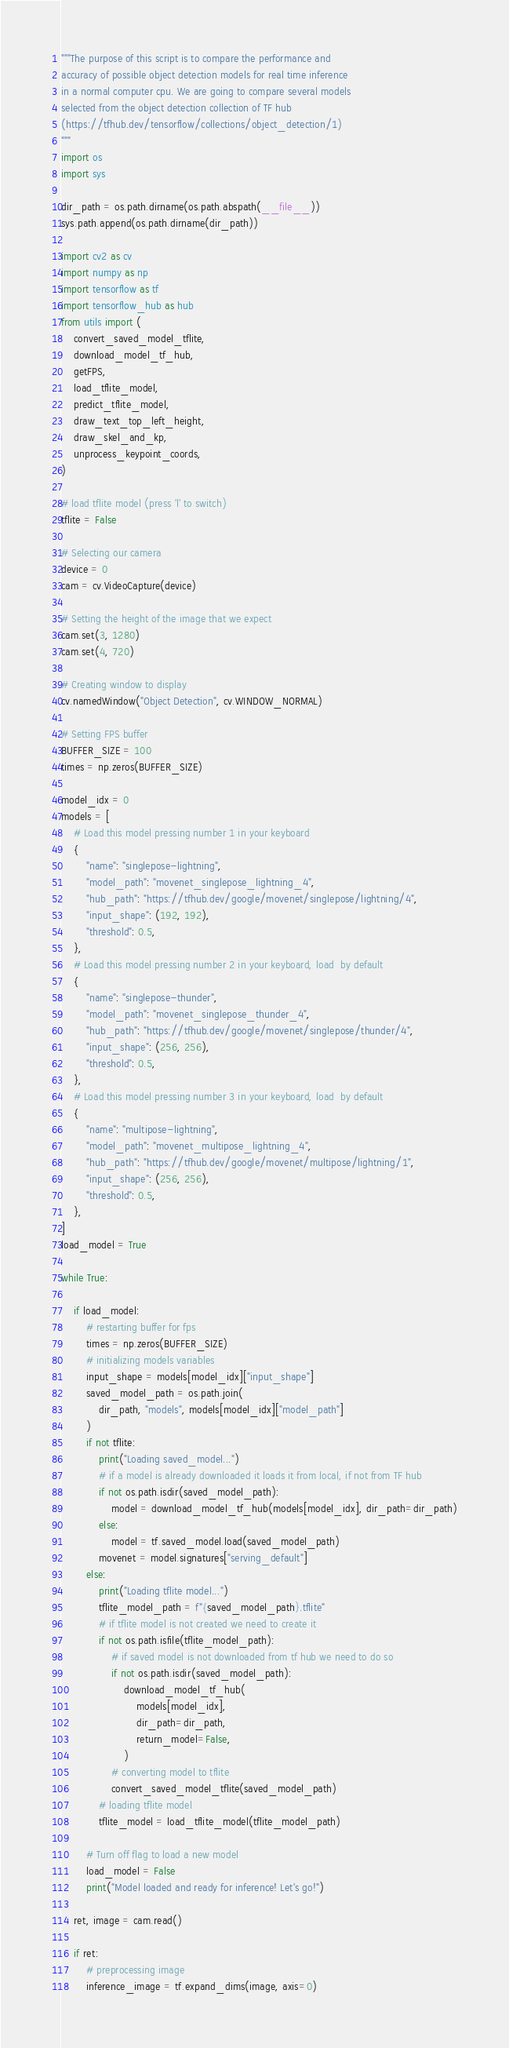Convert code to text. <code><loc_0><loc_0><loc_500><loc_500><_Python_>"""The purpose of this script is to compare the performance and
accuracy of possible object detection models for real time inference
in a normal computer cpu. We are going to compare several models 
selected from the object detection collection of TF hub 
(https://tfhub.dev/tensorflow/collections/object_detection/1)
"""
import os
import sys

dir_path = os.path.dirname(os.path.abspath(__file__))
sys.path.append(os.path.dirname(dir_path))

import cv2 as cv
import numpy as np
import tensorflow as tf
import tensorflow_hub as hub
from utils import (
    convert_saved_model_tflite,
    download_model_tf_hub,
    getFPS,
    load_tflite_model,
    predict_tflite_model,
    draw_text_top_left_height,
    draw_skel_and_kp,
    unprocess_keypoint_coords,
)

# load tflite model (press 'l' to switch)
tflite = False

# Selecting our camera
device = 0
cam = cv.VideoCapture(device)

# Setting the height of the image that we expect
cam.set(3, 1280)
cam.set(4, 720)

# Creating window to display
cv.namedWindow("Object Detection", cv.WINDOW_NORMAL)

# Setting FPS buffer
BUFFER_SIZE = 100
times = np.zeros(BUFFER_SIZE)

model_idx = 0
models = [
    # Load this model pressing number 1 in your keyboard
    {
        "name": "singlepose-lightning",
        "model_path": "movenet_singlepose_lightning_4",
        "hub_path": "https://tfhub.dev/google/movenet/singlepose/lightning/4",
        "input_shape": (192, 192),
        "threshold": 0.5,
    },
    # Load this model pressing number 2 in your keyboard, load  by default
    {
        "name": "singlepose-thunder",
        "model_path": "movenet_singlepose_thunder_4",
        "hub_path": "https://tfhub.dev/google/movenet/singlepose/thunder/4",
        "input_shape": (256, 256),
        "threshold": 0.5,
    },
    # Load this model pressing number 3 in your keyboard, load  by default
    {
        "name": "multipose-lightning",
        "model_path": "movenet_multipose_lightning_4",
        "hub_path": "https://tfhub.dev/google/movenet/multipose/lightning/1",
        "input_shape": (256, 256),
        "threshold": 0.5,
    },
]
load_model = True

while True:

    if load_model:
        # restarting buffer for fps
        times = np.zeros(BUFFER_SIZE)
        # initializing models variables
        input_shape = models[model_idx]["input_shape"]
        saved_model_path = os.path.join(
            dir_path, "models", models[model_idx]["model_path"]
        )
        if not tflite:
            print("Loading saved_model...")
            # if a model is already downloaded it loads it from local, if not from TF hub
            if not os.path.isdir(saved_model_path):
                model = download_model_tf_hub(models[model_idx], dir_path=dir_path)
            else:
                model = tf.saved_model.load(saved_model_path)
            movenet = model.signatures["serving_default"]
        else:
            print("Loading tflite model...")
            tflite_model_path = f"{saved_model_path}.tflite"
            # if tflite model is not created we need to create it
            if not os.path.isfile(tflite_model_path):
                # if saved model is not downloaded from tf hub we need to do so
                if not os.path.isdir(saved_model_path):
                    download_model_tf_hub(
                        models[model_idx],
                        dir_path=dir_path,
                        return_model=False,
                    )
                # converting model to tflite
                convert_saved_model_tflite(saved_model_path)
            # loading tflite model
            tflite_model = load_tflite_model(tflite_model_path)

        # Turn off flag to load a new model
        load_model = False
        print("Model loaded and ready for inference! Let's go!")

    ret, image = cam.read()

    if ret:
        # preprocessing image
        inference_image = tf.expand_dims(image, axis=0)</code> 